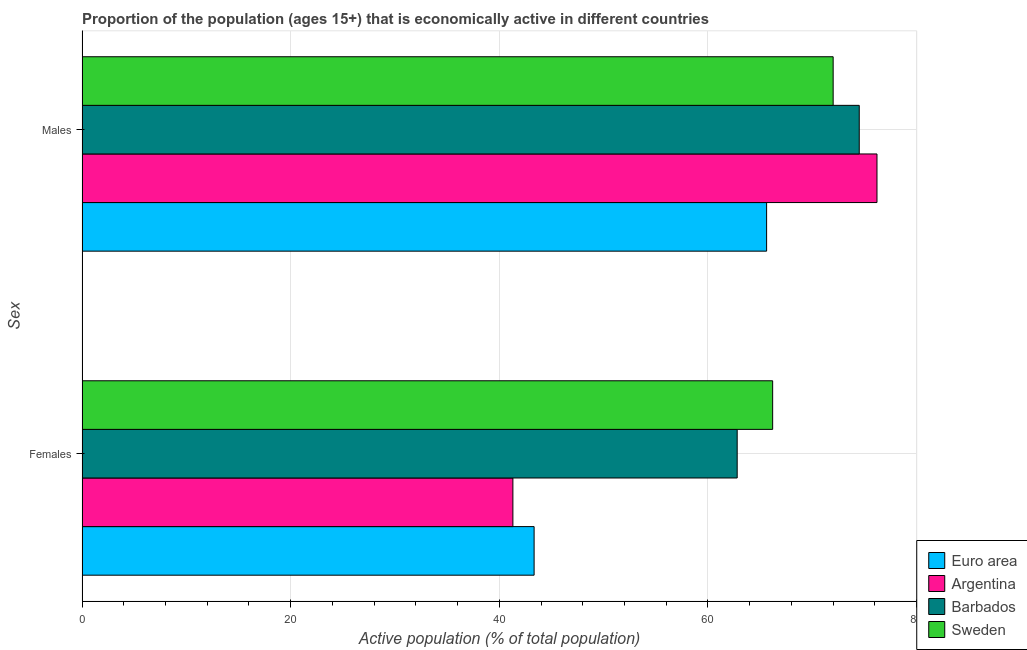How many different coloured bars are there?
Make the answer very short. 4. How many groups of bars are there?
Provide a succinct answer. 2. Are the number of bars on each tick of the Y-axis equal?
Keep it short and to the point. Yes. How many bars are there on the 1st tick from the top?
Offer a terse response. 4. How many bars are there on the 2nd tick from the bottom?
Ensure brevity in your answer.  4. What is the label of the 1st group of bars from the top?
Your answer should be compact. Males. What is the percentage of economically active male population in Argentina?
Keep it short and to the point. 76.2. Across all countries, what is the maximum percentage of economically active male population?
Give a very brief answer. 76.2. Across all countries, what is the minimum percentage of economically active female population?
Ensure brevity in your answer.  41.3. In which country was the percentage of economically active male population maximum?
Make the answer very short. Argentina. In which country was the percentage of economically active male population minimum?
Offer a very short reply. Euro area. What is the total percentage of economically active male population in the graph?
Make the answer very short. 288.32. What is the difference between the percentage of economically active female population in Euro area and that in Barbados?
Offer a very short reply. -19.47. What is the difference between the percentage of economically active male population in Argentina and the percentage of economically active female population in Euro area?
Provide a succinct answer. 32.87. What is the average percentage of economically active female population per country?
Your response must be concise. 53.41. What is the difference between the percentage of economically active female population and percentage of economically active male population in Barbados?
Your answer should be very brief. -11.7. In how many countries, is the percentage of economically active female population greater than 52 %?
Your answer should be compact. 2. What is the ratio of the percentage of economically active male population in Argentina to that in Euro area?
Offer a very short reply. 1.16. Is the percentage of economically active female population in Barbados less than that in Euro area?
Your answer should be very brief. No. In how many countries, is the percentage of economically active male population greater than the average percentage of economically active male population taken over all countries?
Your answer should be very brief. 2. What does the 3rd bar from the bottom in Females represents?
Your response must be concise. Barbados. How many countries are there in the graph?
Keep it short and to the point. 4. What is the difference between two consecutive major ticks on the X-axis?
Give a very brief answer. 20. Does the graph contain any zero values?
Provide a succinct answer. No. How many legend labels are there?
Provide a short and direct response. 4. How are the legend labels stacked?
Your answer should be very brief. Vertical. What is the title of the graph?
Keep it short and to the point. Proportion of the population (ages 15+) that is economically active in different countries. Does "Mozambique" appear as one of the legend labels in the graph?
Provide a succinct answer. No. What is the label or title of the X-axis?
Give a very brief answer. Active population (% of total population). What is the label or title of the Y-axis?
Provide a short and direct response. Sex. What is the Active population (% of total population) in Euro area in Females?
Keep it short and to the point. 43.33. What is the Active population (% of total population) of Argentina in Females?
Offer a terse response. 41.3. What is the Active population (% of total population) of Barbados in Females?
Provide a succinct answer. 62.8. What is the Active population (% of total population) in Sweden in Females?
Offer a terse response. 66.2. What is the Active population (% of total population) in Euro area in Males?
Provide a short and direct response. 65.62. What is the Active population (% of total population) of Argentina in Males?
Provide a short and direct response. 76.2. What is the Active population (% of total population) of Barbados in Males?
Make the answer very short. 74.5. What is the Active population (% of total population) in Sweden in Males?
Provide a succinct answer. 72. Across all Sex, what is the maximum Active population (% of total population) in Euro area?
Give a very brief answer. 65.62. Across all Sex, what is the maximum Active population (% of total population) in Argentina?
Keep it short and to the point. 76.2. Across all Sex, what is the maximum Active population (% of total population) of Barbados?
Keep it short and to the point. 74.5. Across all Sex, what is the minimum Active population (% of total population) in Euro area?
Ensure brevity in your answer.  43.33. Across all Sex, what is the minimum Active population (% of total population) in Argentina?
Offer a very short reply. 41.3. Across all Sex, what is the minimum Active population (% of total population) in Barbados?
Your response must be concise. 62.8. Across all Sex, what is the minimum Active population (% of total population) in Sweden?
Make the answer very short. 66.2. What is the total Active population (% of total population) in Euro area in the graph?
Your answer should be very brief. 108.95. What is the total Active population (% of total population) of Argentina in the graph?
Your response must be concise. 117.5. What is the total Active population (% of total population) of Barbados in the graph?
Offer a very short reply. 137.3. What is the total Active population (% of total population) of Sweden in the graph?
Keep it short and to the point. 138.2. What is the difference between the Active population (% of total population) in Euro area in Females and that in Males?
Offer a very short reply. -22.29. What is the difference between the Active population (% of total population) of Argentina in Females and that in Males?
Offer a terse response. -34.9. What is the difference between the Active population (% of total population) in Euro area in Females and the Active population (% of total population) in Argentina in Males?
Keep it short and to the point. -32.87. What is the difference between the Active population (% of total population) of Euro area in Females and the Active population (% of total population) of Barbados in Males?
Offer a very short reply. -31.17. What is the difference between the Active population (% of total population) of Euro area in Females and the Active population (% of total population) of Sweden in Males?
Give a very brief answer. -28.67. What is the difference between the Active population (% of total population) of Argentina in Females and the Active population (% of total population) of Barbados in Males?
Offer a very short reply. -33.2. What is the difference between the Active population (% of total population) of Argentina in Females and the Active population (% of total population) of Sweden in Males?
Keep it short and to the point. -30.7. What is the average Active population (% of total population) in Euro area per Sex?
Provide a short and direct response. 54.48. What is the average Active population (% of total population) in Argentina per Sex?
Give a very brief answer. 58.75. What is the average Active population (% of total population) of Barbados per Sex?
Offer a very short reply. 68.65. What is the average Active population (% of total population) of Sweden per Sex?
Provide a succinct answer. 69.1. What is the difference between the Active population (% of total population) in Euro area and Active population (% of total population) in Argentina in Females?
Ensure brevity in your answer.  2.03. What is the difference between the Active population (% of total population) of Euro area and Active population (% of total population) of Barbados in Females?
Keep it short and to the point. -19.47. What is the difference between the Active population (% of total population) of Euro area and Active population (% of total population) of Sweden in Females?
Keep it short and to the point. -22.87. What is the difference between the Active population (% of total population) in Argentina and Active population (% of total population) in Barbados in Females?
Ensure brevity in your answer.  -21.5. What is the difference between the Active population (% of total population) of Argentina and Active population (% of total population) of Sweden in Females?
Your answer should be very brief. -24.9. What is the difference between the Active population (% of total population) of Euro area and Active population (% of total population) of Argentina in Males?
Your answer should be very brief. -10.58. What is the difference between the Active population (% of total population) of Euro area and Active population (% of total population) of Barbados in Males?
Make the answer very short. -8.88. What is the difference between the Active population (% of total population) in Euro area and Active population (% of total population) in Sweden in Males?
Make the answer very short. -6.38. What is the difference between the Active population (% of total population) in Argentina and Active population (% of total population) in Barbados in Males?
Provide a succinct answer. 1.7. What is the difference between the Active population (% of total population) of Argentina and Active population (% of total population) of Sweden in Males?
Make the answer very short. 4.2. What is the ratio of the Active population (% of total population) in Euro area in Females to that in Males?
Give a very brief answer. 0.66. What is the ratio of the Active population (% of total population) in Argentina in Females to that in Males?
Your response must be concise. 0.54. What is the ratio of the Active population (% of total population) in Barbados in Females to that in Males?
Offer a very short reply. 0.84. What is the ratio of the Active population (% of total population) in Sweden in Females to that in Males?
Your response must be concise. 0.92. What is the difference between the highest and the second highest Active population (% of total population) of Euro area?
Your answer should be very brief. 22.29. What is the difference between the highest and the second highest Active population (% of total population) of Argentina?
Make the answer very short. 34.9. What is the difference between the highest and the second highest Active population (% of total population) of Sweden?
Your answer should be compact. 5.8. What is the difference between the highest and the lowest Active population (% of total population) of Euro area?
Provide a short and direct response. 22.29. What is the difference between the highest and the lowest Active population (% of total population) in Argentina?
Offer a terse response. 34.9. What is the difference between the highest and the lowest Active population (% of total population) in Barbados?
Your answer should be compact. 11.7. What is the difference between the highest and the lowest Active population (% of total population) of Sweden?
Keep it short and to the point. 5.8. 